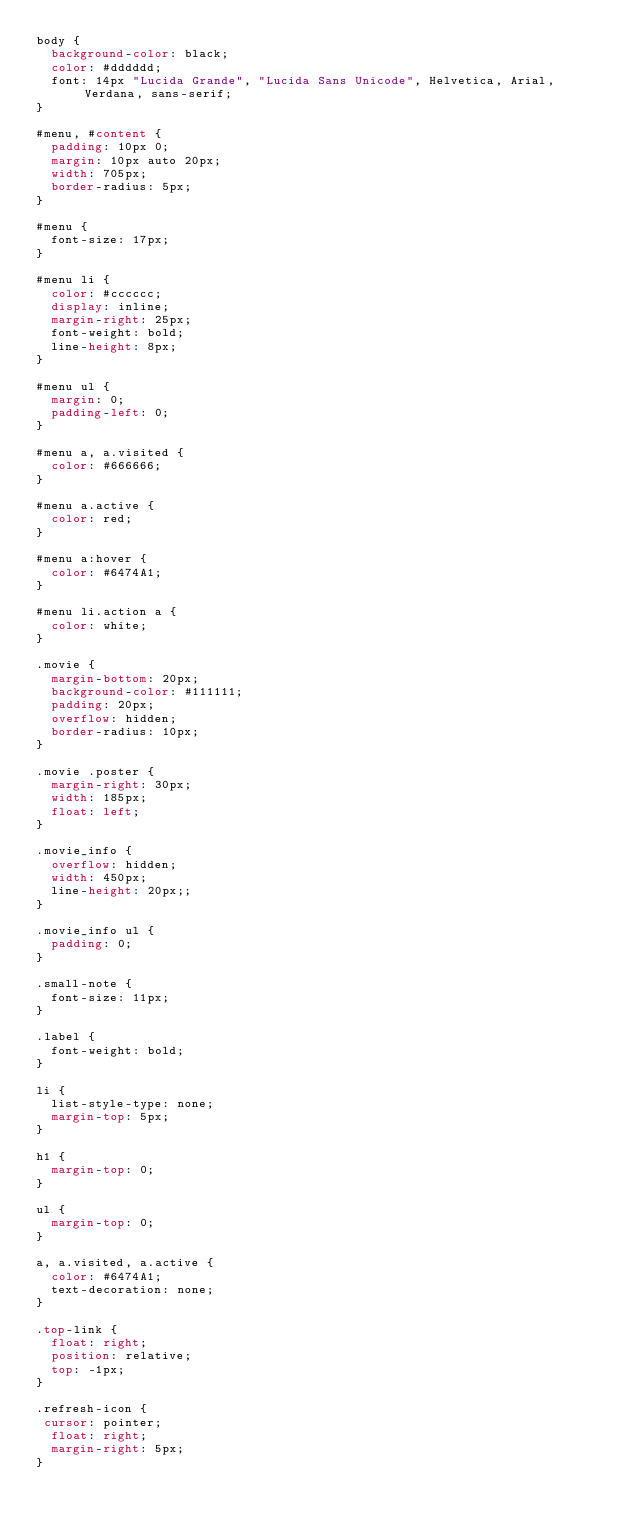<code> <loc_0><loc_0><loc_500><loc_500><_CSS_>body {
  background-color: black;
  color: #dddddd;
  font: 14px "Lucida Grande", "Lucida Sans Unicode", Helvetica, Arial, Verdana, sans-serif;
}

#menu, #content {
  padding: 10px 0;
  margin: 10px auto 20px;
  width: 705px;
  border-radius: 5px;
}

#menu {
  font-size: 17px;
}

#menu li {
  color: #cccccc;
  display: inline;
  margin-right: 25px;
  font-weight: bold;
  line-height: 8px;
}

#menu ul {
  margin: 0;
  padding-left: 0;
}

#menu a, a.visited {
  color: #666666;
}

#menu a.active {
  color: red;
}

#menu a:hover {
  color: #6474A1;
}

#menu li.action a {
  color: white;
}

.movie {
  margin-bottom: 20px;
  background-color: #111111;
  padding: 20px;
  overflow: hidden;
  border-radius: 10px;
}

.movie .poster {
  margin-right: 30px;
  width: 185px;
  float: left;
}

.movie_info {
  overflow: hidden;
  width: 450px;
  line-height: 20px;;
}

.movie_info ul {
  padding: 0;
}

.small-note {
  font-size: 11px;
}

.label {
  font-weight: bold;
}

li {
  list-style-type: none;
  margin-top: 5px;
}

h1 {
  margin-top: 0;
}

ul {
  margin-top: 0;
}

a, a.visited, a.active {
  color: #6474A1;
  text-decoration: none;
}

.top-link {
  float: right;
  position: relative;
  top: -1px;
}

.refresh-icon {
 cursor: pointer;
  float: right;
  margin-right: 5px;
}</code> 